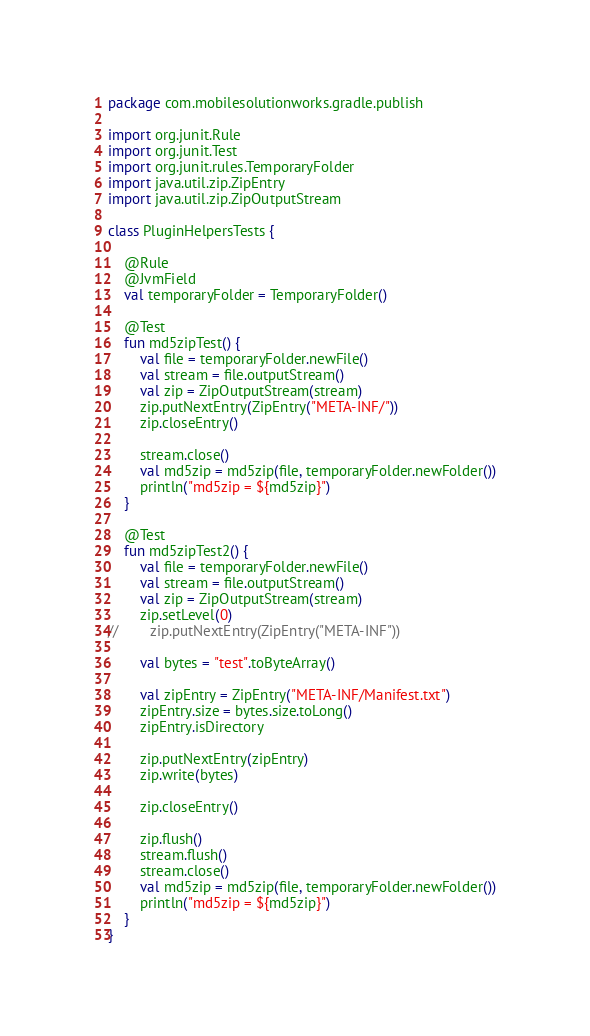<code> <loc_0><loc_0><loc_500><loc_500><_Kotlin_>package com.mobilesolutionworks.gradle.publish

import org.junit.Rule
import org.junit.Test
import org.junit.rules.TemporaryFolder
import java.util.zip.ZipEntry
import java.util.zip.ZipOutputStream

class PluginHelpersTests {

    @Rule
    @JvmField
    val temporaryFolder = TemporaryFolder()

    @Test
    fun md5zipTest() {
        val file = temporaryFolder.newFile()
        val stream = file.outputStream()
        val zip = ZipOutputStream(stream)
        zip.putNextEntry(ZipEntry("META-INF/"))
        zip.closeEntry()

        stream.close()
        val md5zip = md5zip(file, temporaryFolder.newFolder())
        println("md5zip = ${md5zip}")
    }

    @Test
    fun md5zipTest2() {
        val file = temporaryFolder.newFile()
        val stream = file.outputStream()
        val zip = ZipOutputStream(stream)
        zip.setLevel(0)
//        zip.putNextEntry(ZipEntry("META-INF"))

        val bytes = "test".toByteArray()

        val zipEntry = ZipEntry("META-INF/Manifest.txt")
        zipEntry.size = bytes.size.toLong()
        zipEntry.isDirectory

        zip.putNextEntry(zipEntry)
        zip.write(bytes)

        zip.closeEntry()

        zip.flush()
        stream.flush()
        stream.close()
        val md5zip = md5zip(file, temporaryFolder.newFolder())
        println("md5zip = ${md5zip}")
    }
}
</code> 